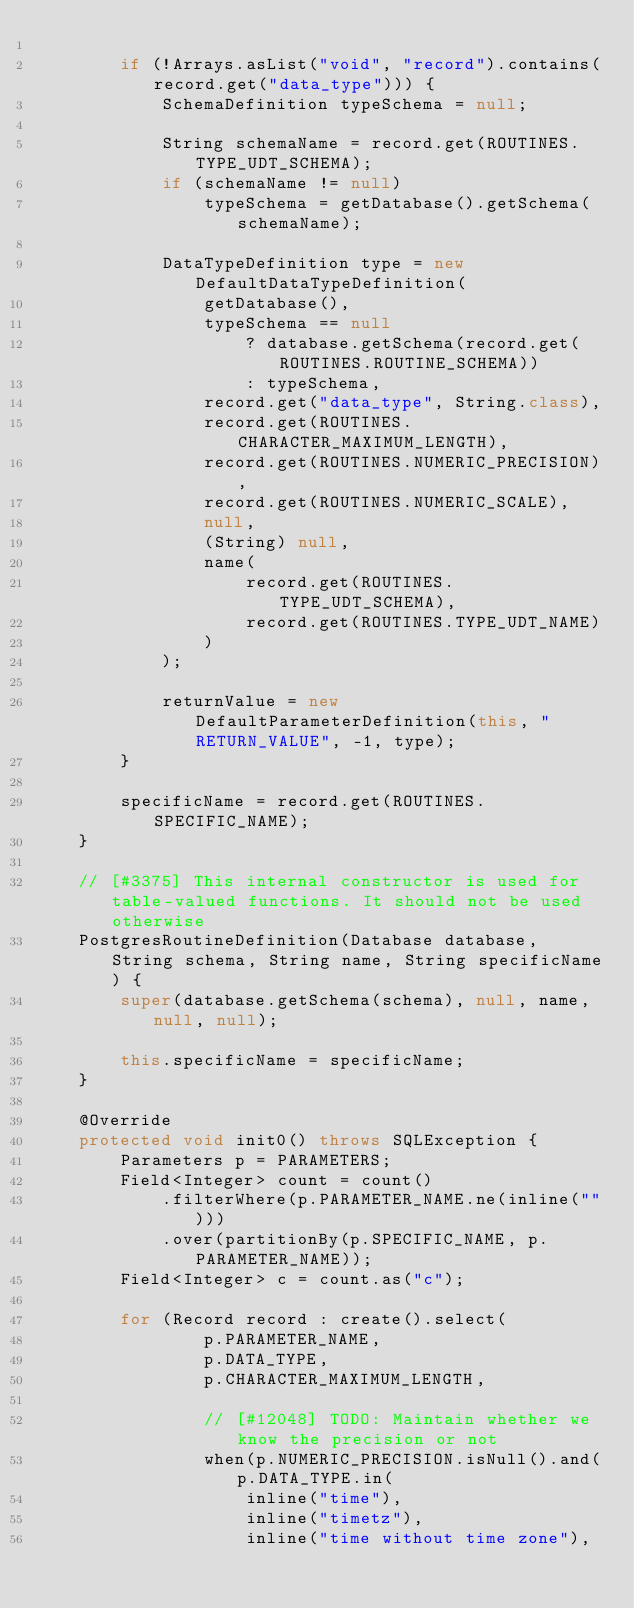<code> <loc_0><loc_0><loc_500><loc_500><_Java_>
        if (!Arrays.asList("void", "record").contains(record.get("data_type"))) {
            SchemaDefinition typeSchema = null;

            String schemaName = record.get(ROUTINES.TYPE_UDT_SCHEMA);
            if (schemaName != null)
                typeSchema = getDatabase().getSchema(schemaName);

            DataTypeDefinition type = new DefaultDataTypeDefinition(
                getDatabase(),
                typeSchema == null
                    ? database.getSchema(record.get(ROUTINES.ROUTINE_SCHEMA))
                    : typeSchema,
                record.get("data_type", String.class),
                record.get(ROUTINES.CHARACTER_MAXIMUM_LENGTH),
                record.get(ROUTINES.NUMERIC_PRECISION),
                record.get(ROUTINES.NUMERIC_SCALE),
                null,
                (String) null,
                name(
                    record.get(ROUTINES.TYPE_UDT_SCHEMA),
                    record.get(ROUTINES.TYPE_UDT_NAME)
                )
            );

            returnValue = new DefaultParameterDefinition(this, "RETURN_VALUE", -1, type);
        }

        specificName = record.get(ROUTINES.SPECIFIC_NAME);
    }

    // [#3375] This internal constructor is used for table-valued functions. It should not be used otherwise
    PostgresRoutineDefinition(Database database, String schema, String name, String specificName) {
        super(database.getSchema(schema), null, name, null, null);

        this.specificName = specificName;
    }

    @Override
    protected void init0() throws SQLException {
        Parameters p = PARAMETERS;
        Field<Integer> count = count()
            .filterWhere(p.PARAMETER_NAME.ne(inline("")))
            .over(partitionBy(p.SPECIFIC_NAME, p.PARAMETER_NAME));
        Field<Integer> c = count.as("c");

        for (Record record : create().select(
                p.PARAMETER_NAME,
                p.DATA_TYPE,
                p.CHARACTER_MAXIMUM_LENGTH,

                // [#12048] TODO: Maintain whether we know the precision or not
                when(p.NUMERIC_PRECISION.isNull().and(p.DATA_TYPE.in(
                    inline("time"),
                    inline("timetz"),
                    inline("time without time zone"),</code> 